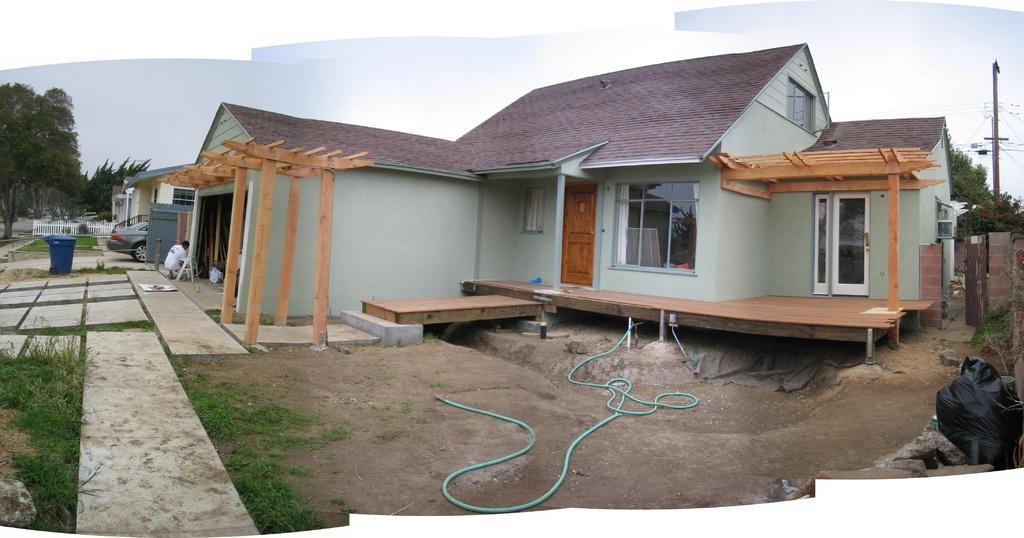Could you give a brief overview of what you see in this image? This is an outside view. In the middle of the image I can see few houses. On the right and left side of the image I can see the trees. In the bottom right there is a bag placed on the ground. On the left side there is a car, dustbin and also I can see the fencing. In front of this house there is a rope on the ground. At the top of the image I can see the sky. On the right side there is a pole along with the wires. 